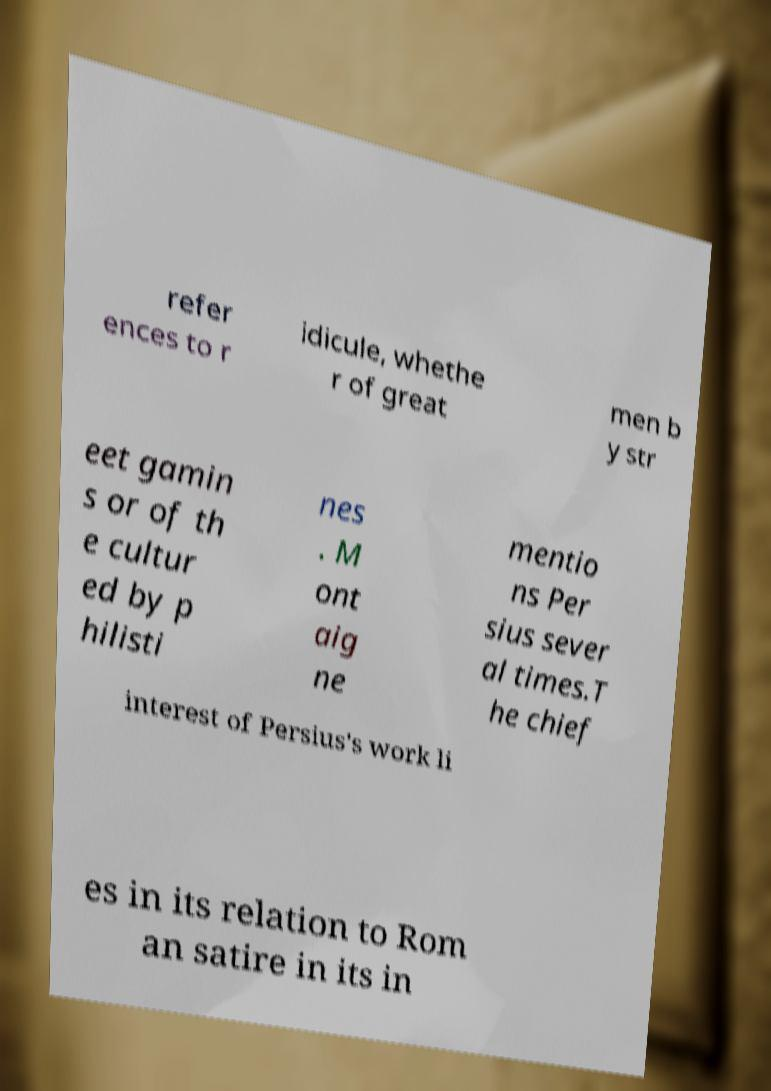For documentation purposes, I need the text within this image transcribed. Could you provide that? refer ences to r idicule, whethe r of great men b y str eet gamin s or of th e cultur ed by p hilisti nes . M ont aig ne mentio ns Per sius sever al times.T he chief interest of Persius's work li es in its relation to Rom an satire in its in 